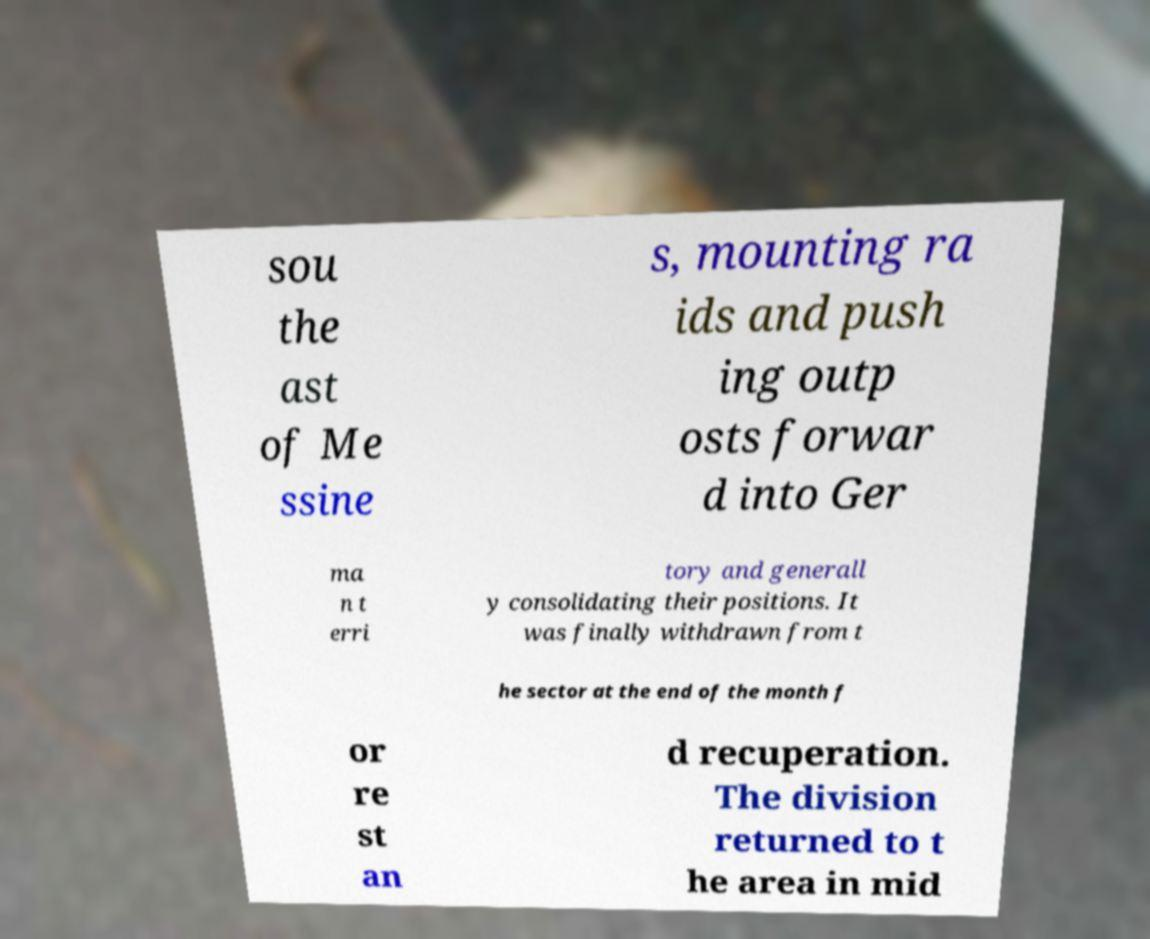Please identify and transcribe the text found in this image. sou the ast of Me ssine s, mounting ra ids and push ing outp osts forwar d into Ger ma n t erri tory and generall y consolidating their positions. It was finally withdrawn from t he sector at the end of the month f or re st an d recuperation. The division returned to t he area in mid 